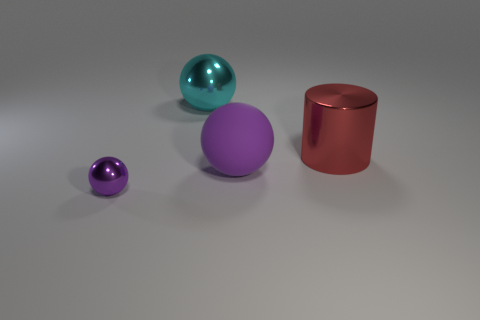What is the material of the other ball that is the same color as the tiny sphere?
Your response must be concise. Rubber. What size is the red cylinder?
Give a very brief answer. Large. How many things are either big blue metallic things or things that are left of the matte ball?
Your answer should be compact. 2. How many other things are there of the same color as the small ball?
Your response must be concise. 1. Does the cyan metal ball have the same size as the metallic ball that is in front of the big metal sphere?
Your answer should be compact. No. Is the size of the shiny ball that is behind the purple matte ball the same as the tiny purple sphere?
Your response must be concise. No. What number of other things are the same material as the big cyan sphere?
Your response must be concise. 2. Are there the same number of large metallic spheres that are left of the big metal ball and large purple things that are right of the red metallic cylinder?
Ensure brevity in your answer.  Yes. There is a big ball in front of the metal sphere behind the tiny purple ball in front of the red cylinder; what is its color?
Your answer should be compact. Purple. What shape is the purple thing that is behind the tiny thing?
Provide a short and direct response. Sphere. 